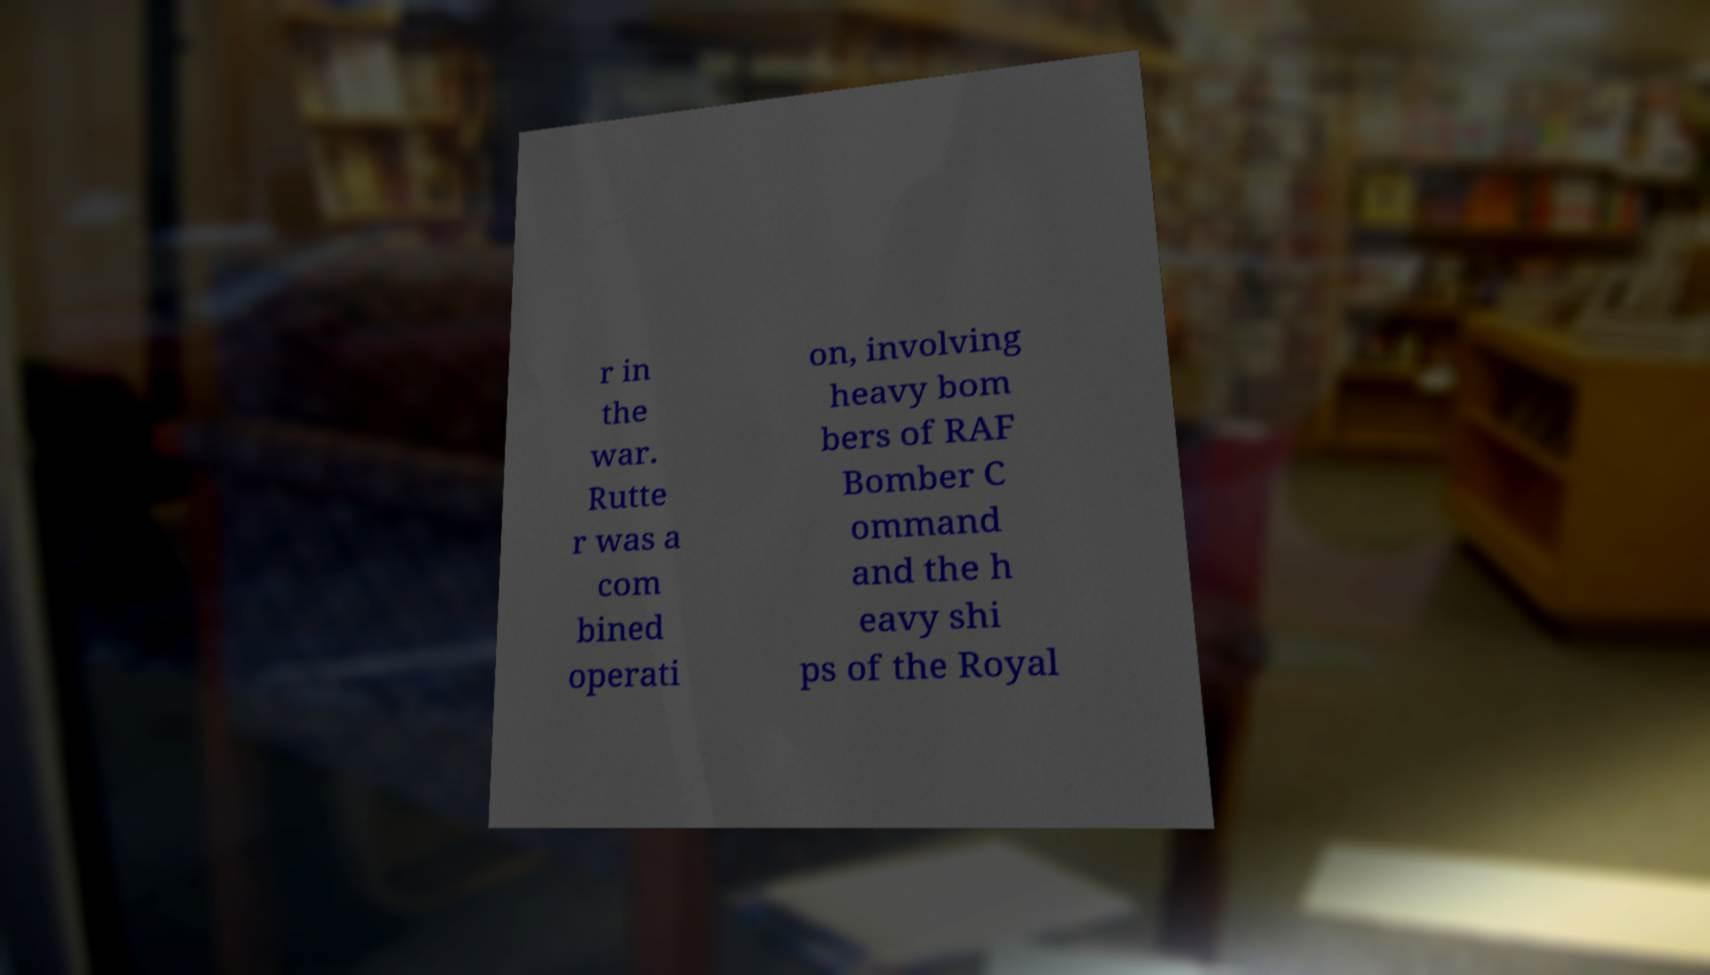Could you extract and type out the text from this image? r in the war. Rutte r was a com bined operati on, involving heavy bom bers of RAF Bomber C ommand and the h eavy shi ps of the Royal 